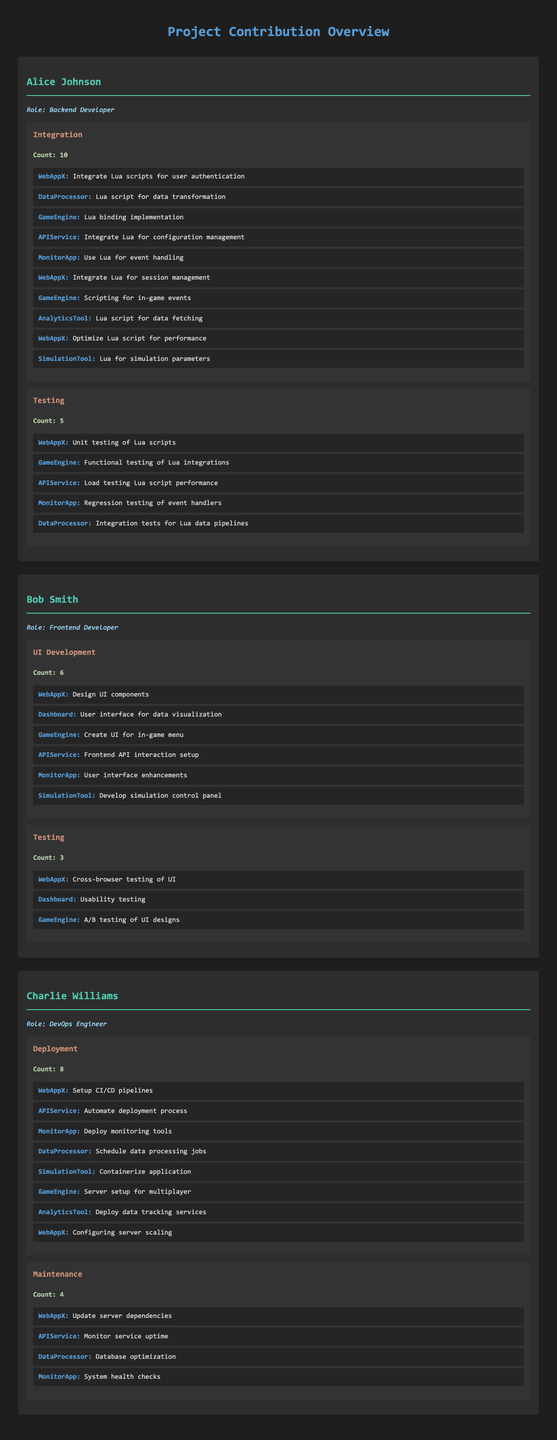What is the total count of contributions made by Alice Johnson? Alice Johnson has contributions in two task types: Integration with a count of 10 and Testing with a count of 5. Adding these together gives 10 + 5 = 15.
Answer: 15 How many projects did Bob Smith contribute to in UI Development? Bob Smith has details listed under UI Development with a count of 6. Each detail corresponds to a specific project, confirming he contributed to 6 projects.
Answer: 6 Did Charlie Williams engage in any testing tasks? There is no mention of any testing tasks under Charlie Williams' contributions; all tasks listed are in Deployment and Maintenance. Therefore, the answer is no.
Answer: No What is the average count of contributions for each developer? To find the average, sum the total contributions from all developers: Alice Johnson (15) + Bob Smith (9) + Charlie Williams (12) = 36. There are 3 developers, so the average is 36 / 3 = 12.
Answer: 12 Which developer has the most contributions in maintenance tasks? Charlie Williams has a count of 4 contributions in Maintenance. The other developers (Alice Johnson and Bob Smith) do not have listed contributions in Maintenance, making Charlie the one with the most contributions in this area.
Answer: Charlie Williams How many total contributions did all developers make in Integration tasks? Alice Johnson has 10 contributions in Integration, while Bob Smith and Charlie Williams do not have any in this category. Therefore, the total count for Integration tasks is solely Alice's contributions, which is 10.
Answer: 10 What is the total number of contributions across all types of tasks for Bob Smith? Bob Smith's contributions include UI Development with 6 contributions and Testing with 3 contributions. Adding these gives 6 + 3 = 9 as the total number of contributions across all types of tasks.
Answer: 9 Which developer contributed to the most projects? Alice Johnson contributed to 10 projects under Integration and 5 projects under Testing, totaling 15 projects. Bob Smith contributed to 6 projects and Charlie Williams contributed to 8 projects, making Alice the developer with the most contributions overall.
Answer: Alice Johnson Do any of the developers have the same total contribution counts? Alice Johnson has 15, Bob Smith has 9, and Charlie Williams has 12, indicating that none of the developers have the same total contribution counts. Therefore, the answer is no.
Answer: No 